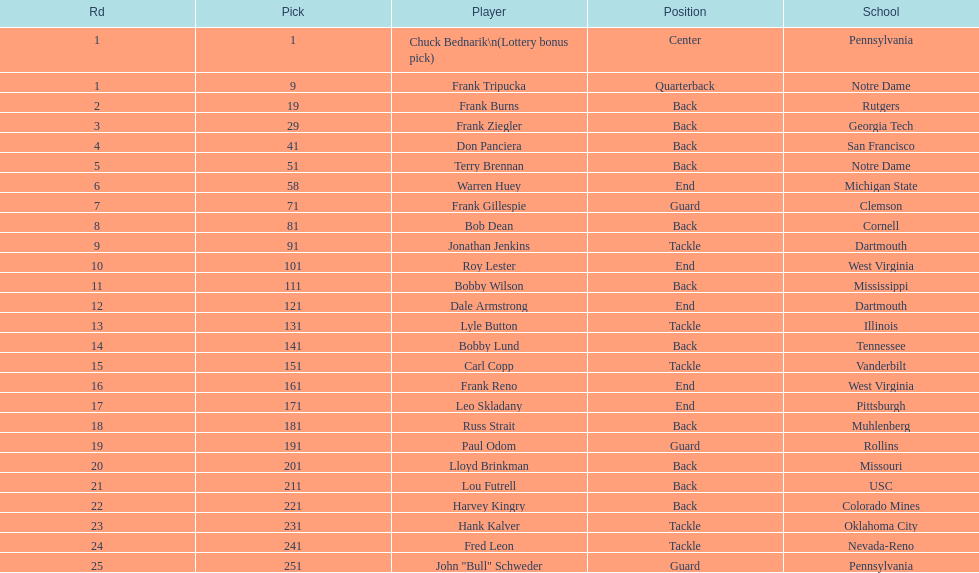Most prevalent school Pennsylvania. 